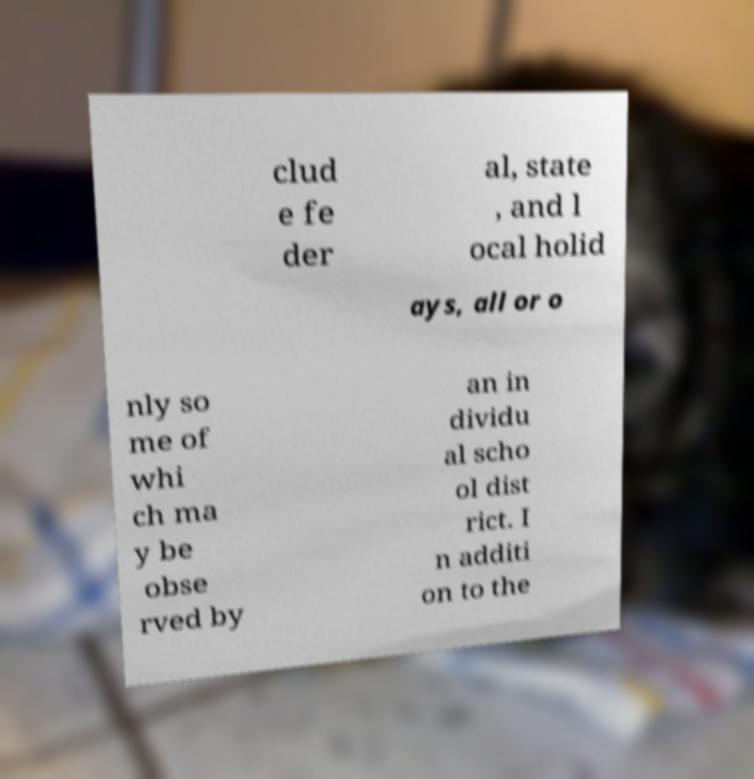Please identify and transcribe the text found in this image. clud e fe der al, state , and l ocal holid ays, all or o nly so me of whi ch ma y be obse rved by an in dividu al scho ol dist rict. I n additi on to the 